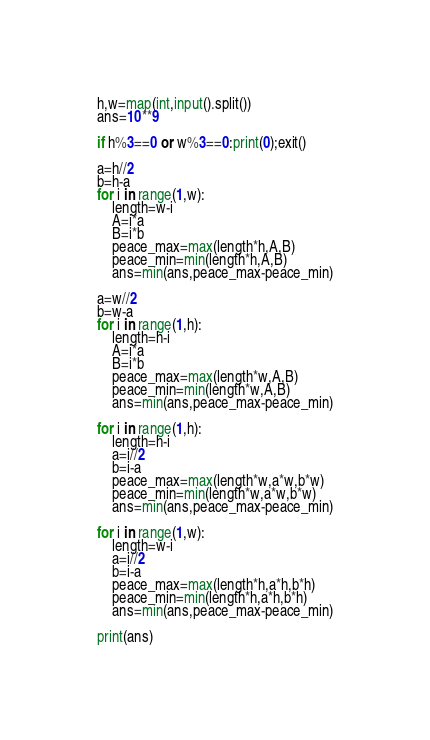Convert code to text. <code><loc_0><loc_0><loc_500><loc_500><_Python_>h,w=map(int,input().split())
ans=10**9

if h%3==0 or w%3==0:print(0);exit()

a=h//2
b=h-a
for i in range(1,w):
    length=w-i
    A=i*a
    B=i*b
    peace_max=max(length*h,A,B)
    peace_min=min(length*h,A,B)
    ans=min(ans,peace_max-peace_min)

a=w//2
b=w-a
for i in range(1,h):
    length=h-i
    A=i*a
    B=i*b
    peace_max=max(length*w,A,B)
    peace_min=min(length*w,A,B)
    ans=min(ans,peace_max-peace_min)

for i in range(1,h):
    length=h-i
    a=i//2
    b=i-a
    peace_max=max(length*w,a*w,b*w)
    peace_min=min(length*w,a*w,b*w)
    ans=min(ans,peace_max-peace_min)
    
for i in range(1,w):
    length=w-i
    a=i//2
    b=i-a
    peace_max=max(length*h,a*h,b*h)
    peace_min=min(length*h,a*h,b*h)
    ans=min(ans,peace_max-peace_min)

print(ans)</code> 